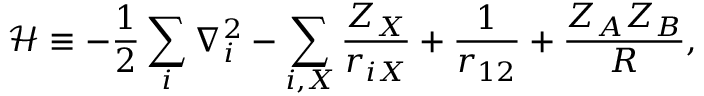Convert formula to latex. <formula><loc_0><loc_0><loc_500><loc_500>\mathcal { H } \equiv - \frac { 1 } { 2 } \sum _ { i } \nabla _ { i } ^ { 2 } - \sum _ { i , X } \frac { Z _ { X } } { r _ { i X } } + \frac { 1 } { r _ { 1 2 } } + \frac { Z _ { A } Z _ { B } } { R } ,</formula> 